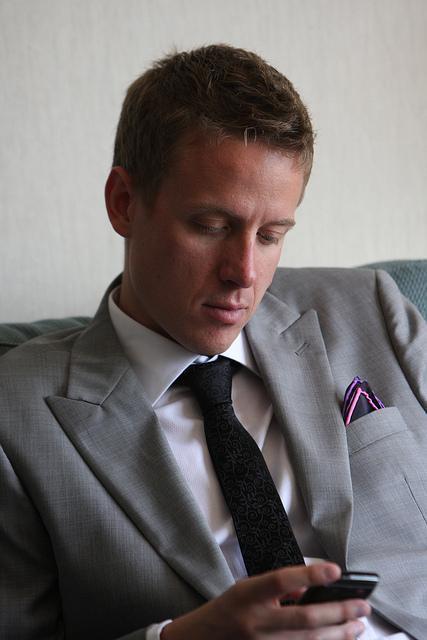Is the given caption "The couch is across from the person." fitting for the image?
Answer yes or no. No. 